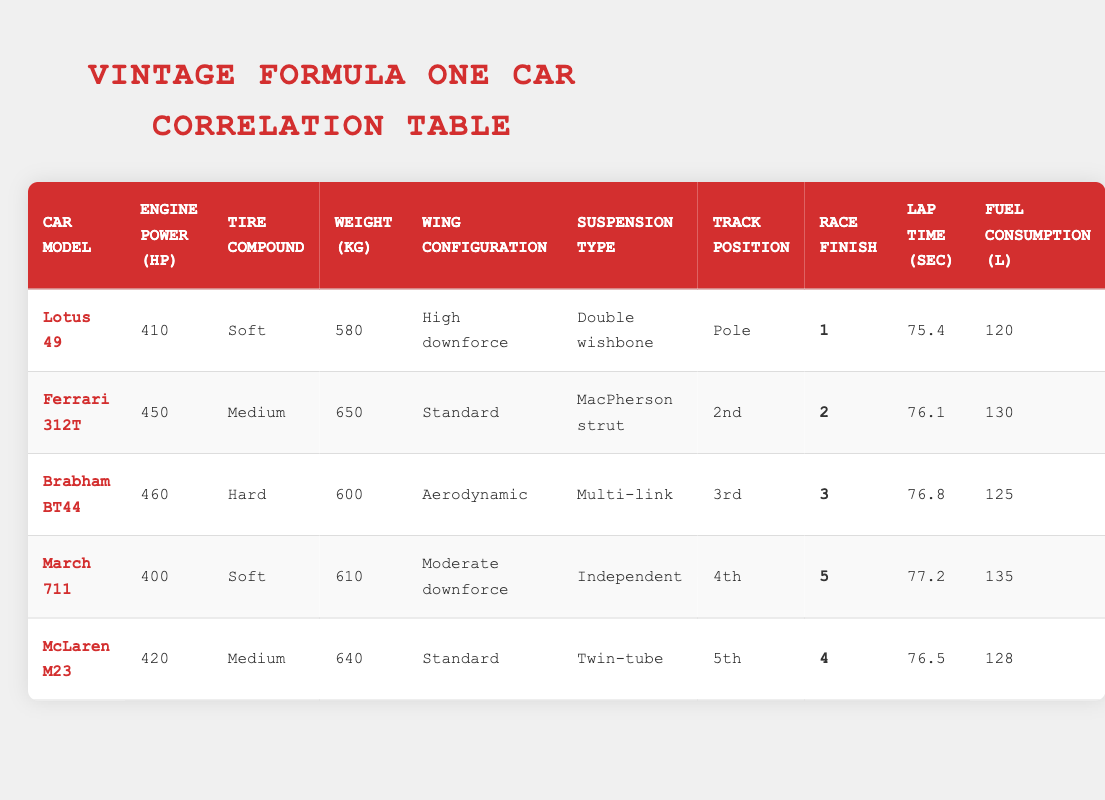What is the engine power of the Ferrari 312T? The table lists the Ferrari 312T in the second row, with the engine power listed under the corresponding column as 450 hp.
Answer: 450 hp Which car has the lowest weight? By examining the weight column, the Lotus 49 is the lightest car at 580 kg.
Answer: 580 kg What is the average lap time of all the cars? To find the average lap time, sum the lap times: 75.4 + 76.1 + 76.8 + 77.2 + 76.5 = 382.0 seconds. Dividing this total (382.0) by 5 cars gives an average lap time of 76.4 seconds.
Answer: 76.4 seconds Did any car have a fuel consumption of 120 liters? The table indicates that the Lotus 49 has a fuel consumption of 120 liters, confirming that yes, there was indeed a car with this consumption.
Answer: Yes What is the race finish position of the Brabham BT44 and how does it compare to the McLaren M23? The Brabham BT44 finished in 3rd position, while the McLaren M23 finished in 4th position. This shows that the Brabham BT44 performed better than the McLaren M23 in the race.
Answer: Brabham BT44: 3rd, McLaren M23: 4th Which car had the highest engine power and what was its race finish position? The Brabham BT44 has the highest engine power at 460 hp and it finished in 3rd position.
Answer: 3rd position What is the difference in fuel consumption between the March 711 and the Ferrari 312T? The March 711 has a fuel consumption of 135 liters while the Ferrari 312T has 130 liters. The difference is 135 - 130 = 5 liters, meaning the March 711 consumes more fuel.
Answer: 5 liters How many cars had a high downforce wing configuration? The table shows that only the Lotus 49 had a high downforce wing configuration. Thus, it is one car.
Answer: 1 car If we consider tracks starting from pole position, how did the cars ranking change from track position to race finish position? The Lotus 49 started in pole position and finished 1st, Ferrari 312T started 2nd and finished 2nd, Brabham BT44 started 3rd and finished 3rd, March 711 started 4th and finished 5th, McLaren M23 started 5th and finished 4th. The performance was consistent for the top three, but the March 711's position dropped while the McLaren improved by one place.
Answer: Consistency in top three, March 711 dropped, McLaren improved 